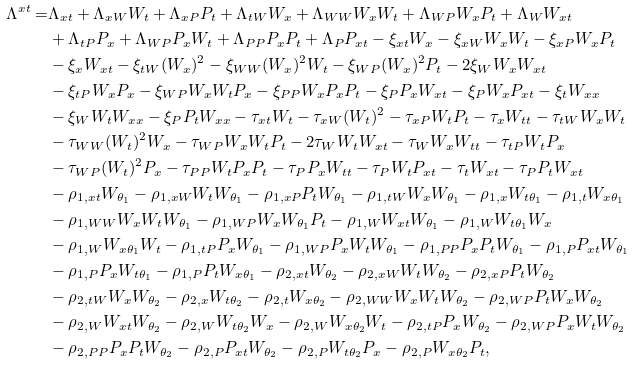<formula> <loc_0><loc_0><loc_500><loc_500>\Lambda ^ { x t } = & \Lambda _ { x t } + \Lambda _ { x W } W _ { t } + \Lambda _ { x P } P _ { t } + \Lambda _ { t W } W _ { x } + \Lambda _ { W W } W _ { x } W _ { t } + \Lambda _ { W P } W _ { x } P _ { t } + \Lambda _ { W } W _ { x t } \\ & + \Lambda _ { t P } P _ { x } + \Lambda _ { W P } P _ { x } W _ { t } + \Lambda _ { P P } P _ { x } P _ { t } + \Lambda _ { P } P _ { x t } - \xi _ { x t } W _ { x } - \xi _ { x W } W _ { x } W _ { t } - \xi _ { x P } W _ { x } P _ { t } \\ & - \xi _ { x } W _ { x t } - \xi _ { t W } ( W _ { x } ) ^ { 2 } - \xi _ { W W } ( W _ { x } ) ^ { 2 } W _ { t } - \xi _ { W P } ( W _ { x } ) ^ { 2 } P _ { t } - 2 \xi _ { W } W _ { x } W _ { x t } \\ & - \xi _ { t P } W _ { x } P _ { x } - \xi _ { W P } W _ { x } W _ { t } P _ { x } - \xi _ { P P } W _ { x } P _ { x } P _ { t } - \xi _ { P } P _ { x } W _ { x t } - \xi _ { P } W _ { x } P _ { x t } - \xi _ { t } W _ { x x } \\ & - \xi _ { W } W _ { t } W _ { x x } - \xi _ { P } P _ { t } W _ { x x } - \tau _ { x t } W _ { t } - \tau _ { x W } ( W _ { t } ) ^ { 2 } - \tau _ { x P } W _ { t } P _ { t } - \tau _ { x } W _ { t t } - \tau _ { t W } W _ { x } W _ { t } \\ & - \tau _ { W W } ( W _ { t } ) ^ { 2 } W _ { x } - \tau _ { W P } W _ { x } W _ { t } P _ { t } - 2 \tau _ { W } W _ { t } W _ { x t } - \tau _ { W } W _ { x } W _ { t t } - \tau _ { t P } W _ { t } P _ { x } \\ & - \tau _ { W P } ( W _ { t } ) ^ { 2 } P _ { x } - \tau _ { P P } W _ { t } P _ { x } P _ { t } - \tau _ { P } P _ { x } W _ { t t } - \tau _ { P } W _ { t } P _ { x t } - \tau _ { t } W _ { x t } - \tau _ { P } P _ { t } W _ { x t } \\ & - \rho _ { 1 , x t } W _ { \theta _ { 1 } } - \rho _ { 1 , x W } W _ { t } W _ { \theta _ { 1 } } - \rho _ { 1 , x P } P _ { t } W _ { \theta _ { 1 } } - \rho _ { 1 , t W } W _ { x } W _ { \theta _ { 1 } } - \rho _ { 1 , x } W _ { t \theta _ { 1 } } - \rho _ { 1 , t } W _ { x \theta _ { 1 } } \\ & - \rho _ { 1 , W W } W _ { x } W _ { t } W _ { \theta _ { 1 } } - \rho _ { 1 , W P } W _ { x } W _ { \theta _ { 1 } } P _ { t } - \rho _ { 1 , W } W _ { x t } W _ { \theta _ { 1 } } - \rho _ { 1 , W } W _ { t \theta _ { 1 } } W _ { x } \\ & - \rho _ { 1 , W } W _ { x \theta _ { 1 } } W _ { t } - \rho _ { 1 , t P } P _ { x } W _ { \theta _ { 1 } } - \rho _ { 1 , W P } P _ { x } W _ { t } W _ { \theta _ { 1 } } - \rho _ { 1 , P P } P _ { x } P _ { t } W _ { \theta _ { 1 } } - \rho _ { 1 , P } P _ { x t } W _ { \theta _ { 1 } } \\ & - \rho _ { 1 , P } P _ { x } W _ { t \theta _ { 1 } } - \rho _ { 1 , P } P _ { t } W _ { x \theta _ { 1 } } - \rho _ { 2 , x t } W _ { \theta _ { 2 } } - \rho _ { 2 , x W } W _ { t } W _ { \theta _ { 2 } } - \rho _ { 2 , x P } P _ { t } W _ { \theta _ { 2 } } \\ & - \rho _ { 2 , t W } W _ { x } W _ { \theta _ { 2 } } - \rho _ { 2 , x } W _ { t \theta _ { 2 } } - \rho _ { 2 , t } W _ { x \theta _ { 2 } } - \rho _ { 2 , W W } W _ { x } W _ { t } W _ { \theta _ { 2 } } - \rho _ { 2 , W P } P _ { t } W _ { x } W _ { \theta _ { 2 } } \\ & - \rho _ { 2 , W } W _ { x t } W _ { \theta _ { 2 } } - \rho _ { 2 , W } W _ { t \theta _ { 2 } } W _ { x } - \rho _ { 2 , W } W _ { x \theta _ { 2 } } W _ { t } - \rho _ { 2 , t P } P _ { x } W _ { \theta _ { 2 } } - \rho _ { 2 , W P } P _ { x } W _ { t } W _ { \theta _ { 2 } } \\ & - \rho _ { 2 , P P } P _ { x } P _ { t } W _ { \theta _ { 2 } } - \rho _ { 2 , P } P _ { x t } W _ { \theta _ { 2 } } - \rho _ { 2 , P } W _ { t \theta _ { 2 } } P _ { x } - \rho _ { 2 , P } W _ { x \theta _ { 2 } } P _ { t } ,</formula> 